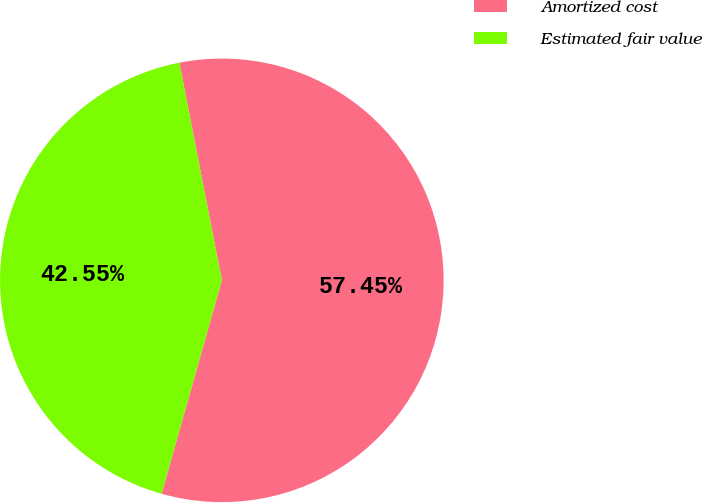Convert chart to OTSL. <chart><loc_0><loc_0><loc_500><loc_500><pie_chart><fcel>Amortized cost<fcel>Estimated fair value<nl><fcel>57.45%<fcel>42.55%<nl></chart> 